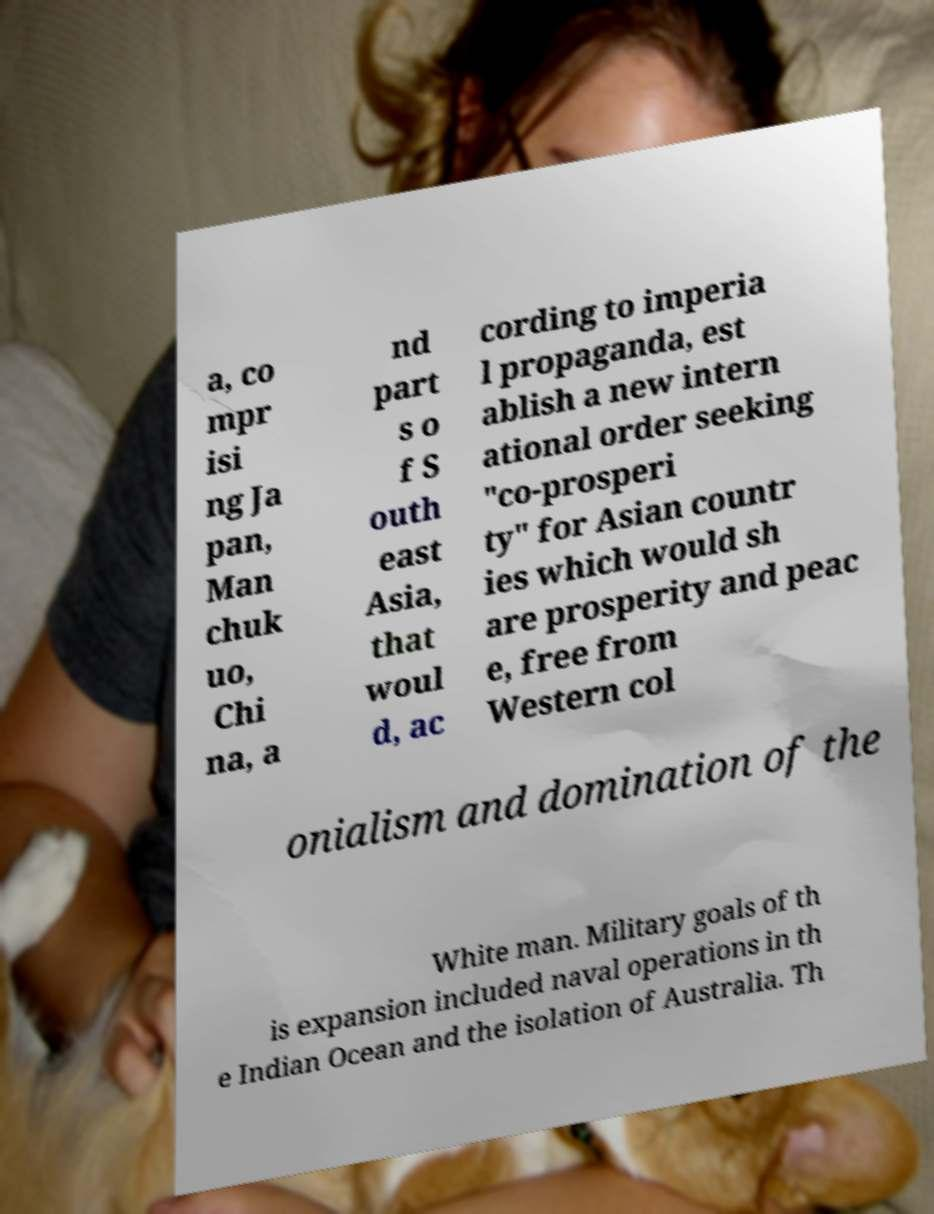Please read and relay the text visible in this image. What does it say? a, co mpr isi ng Ja pan, Man chuk uo, Chi na, a nd part s o f S outh east Asia, that woul d, ac cording to imperia l propaganda, est ablish a new intern ational order seeking "co-prosperi ty" for Asian countr ies which would sh are prosperity and peac e, free from Western col onialism and domination of the White man. Military goals of th is expansion included naval operations in th e Indian Ocean and the isolation of Australia. Th 